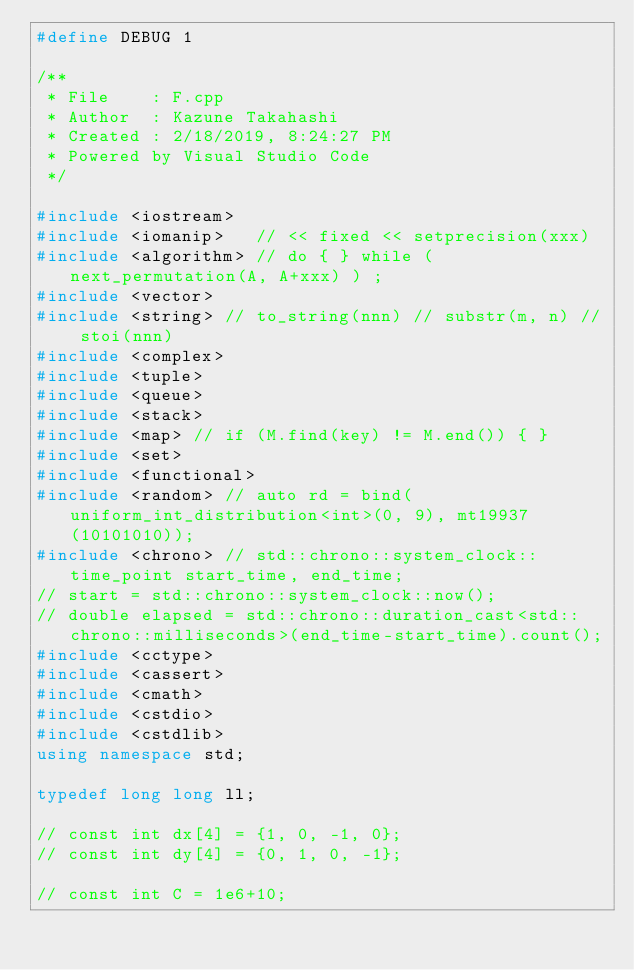Convert code to text. <code><loc_0><loc_0><loc_500><loc_500><_C++_>#define DEBUG 1

/**
 * File    : F.cpp
 * Author  : Kazune Takahashi
 * Created : 2/18/2019, 8:24:27 PM
 * Powered by Visual Studio Code
 */

#include <iostream>
#include <iomanip>   // << fixed << setprecision(xxx)
#include <algorithm> // do { } while ( next_permutation(A, A+xxx) ) ;
#include <vector>
#include <string> // to_string(nnn) // substr(m, n) // stoi(nnn)
#include <complex>
#include <tuple>
#include <queue>
#include <stack>
#include <map> // if (M.find(key) != M.end()) { }
#include <set>
#include <functional>
#include <random> // auto rd = bind(uniform_int_distribution<int>(0, 9), mt19937(10101010));
#include <chrono> // std::chrono::system_clock::time_point start_time, end_time;
// start = std::chrono::system_clock::now();
// double elapsed = std::chrono::duration_cast<std::chrono::milliseconds>(end_time-start_time).count();
#include <cctype>
#include <cassert>
#include <cmath>
#include <cstdio>
#include <cstdlib>
using namespace std;

typedef long long ll;

// const int dx[4] = {1, 0, -1, 0};
// const int dy[4] = {0, 1, 0, -1};

// const int C = 1e6+10;</code> 